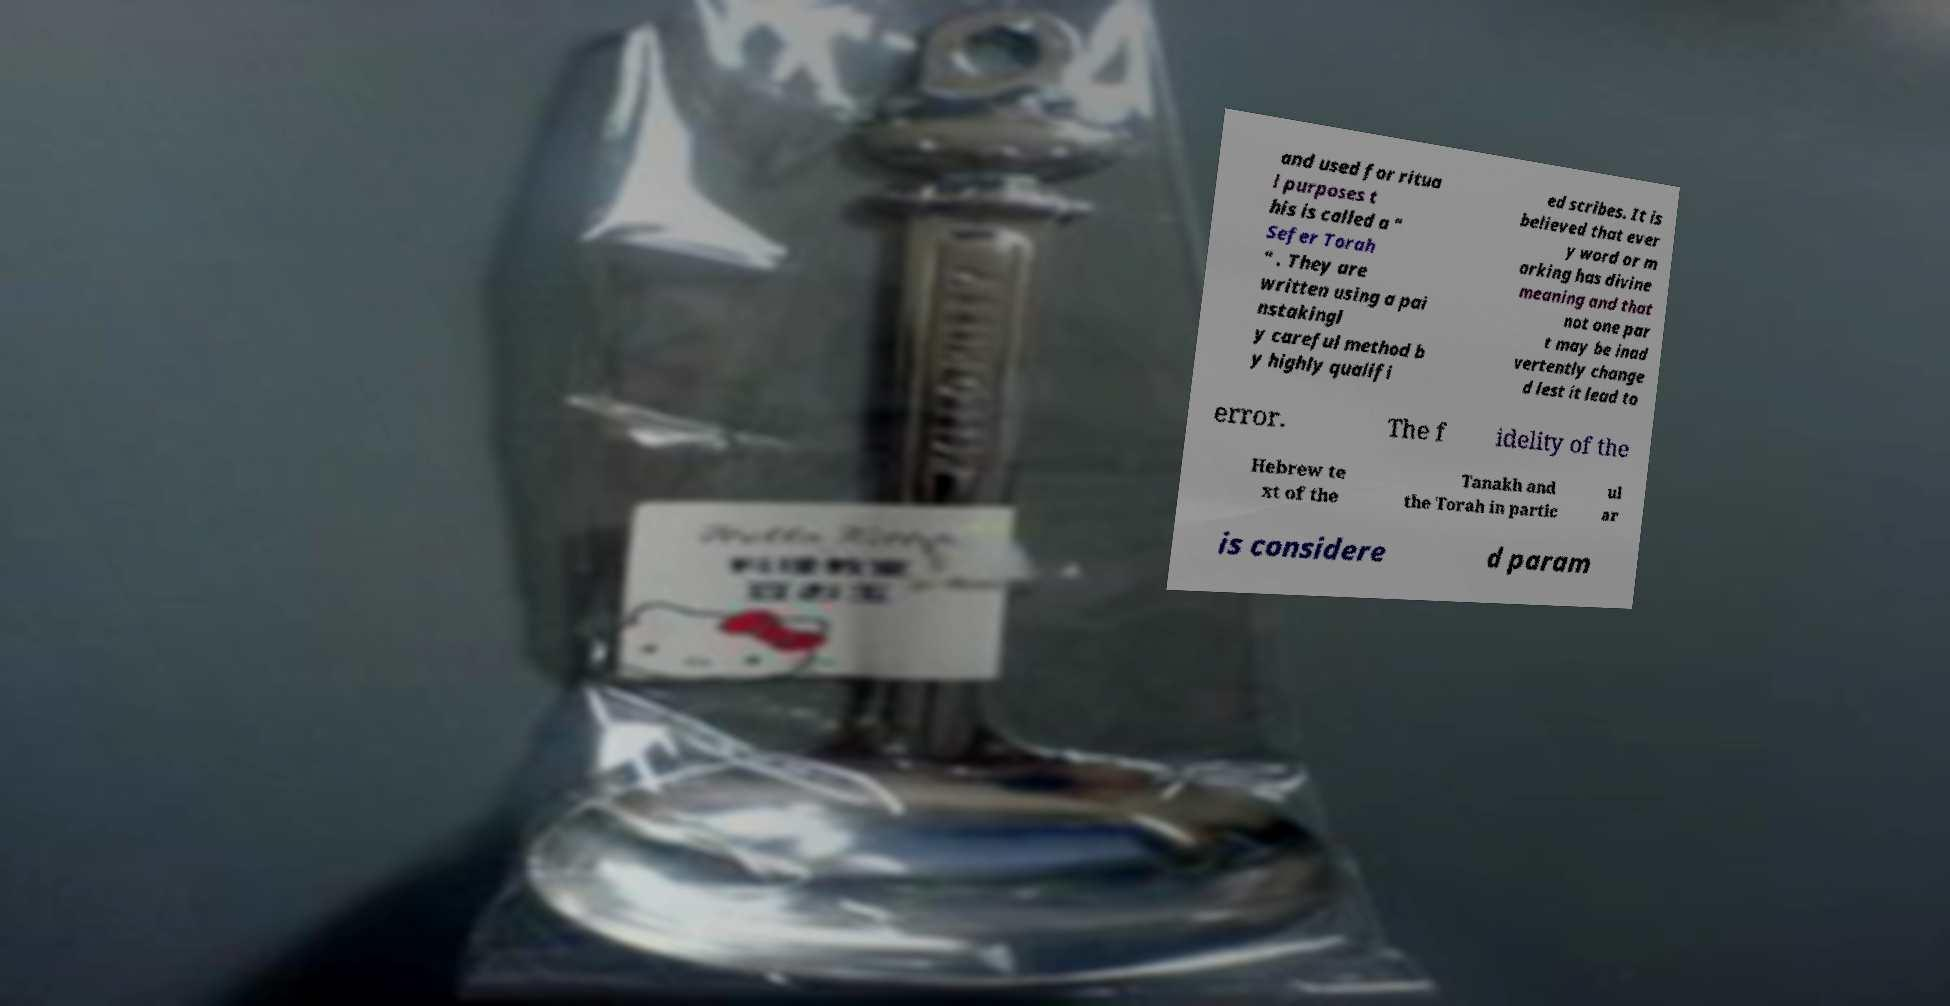There's text embedded in this image that I need extracted. Can you transcribe it verbatim? and used for ritua l purposes t his is called a " Sefer Torah " . They are written using a pai nstakingl y careful method b y highly qualifi ed scribes. It is believed that ever y word or m arking has divine meaning and that not one par t may be inad vertently change d lest it lead to error. The f idelity of the Hebrew te xt of the Tanakh and the Torah in partic ul ar is considere d param 